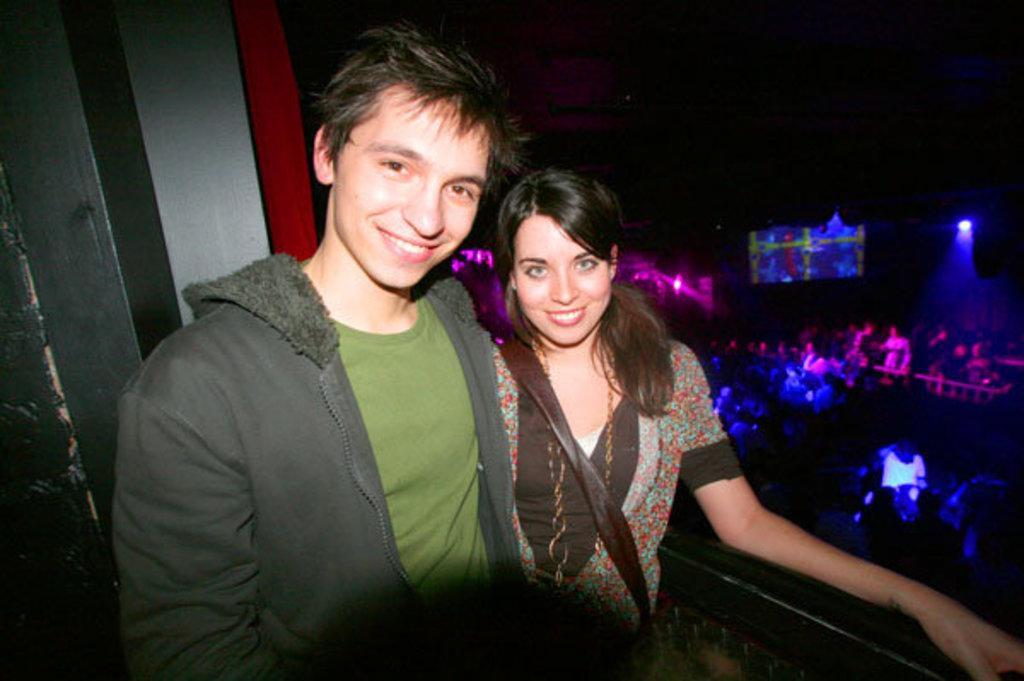Please provide a concise description of this image. In the center of the image we can see two persons are standing and they are smiling and they are in different costumes. At the bottom right side of the image, we can see some object. In the background there is a wall, lights, few people and a few other objects. 